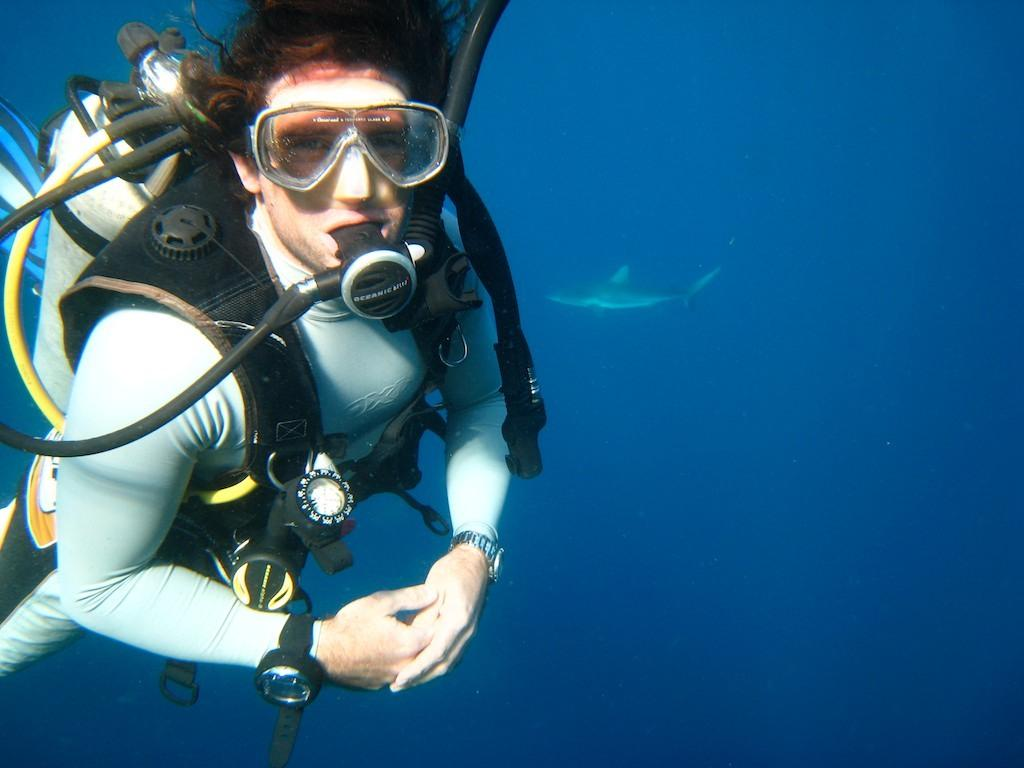Who or what is present in the image? There is a person in the image. What is the person's location in the image? The person is underwater in the image. What is the person using to breathe underwater? There is a wire oxygen cylinder in the image, which the person is likely using to breathe. What is the person wearing in the image? The person is wearing glasses in the image. What other living organisms can be seen in the image? Fish are visible in the image. What type of sweater is the person wearing in the image? The person is not wearing a sweater in the image; they are underwater and wearing glasses. How many cows can be seen in the image? There are no cows present in the image; it features a person underwater with fish and a wire oxygen cylinder. 